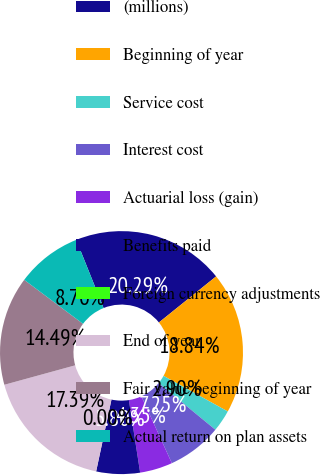Convert chart to OTSL. <chart><loc_0><loc_0><loc_500><loc_500><pie_chart><fcel>(millions)<fcel>Beginning of year<fcel>Service cost<fcel>Interest cost<fcel>Actuarial loss (gain)<fcel>Benefits paid<fcel>Foreign currency adjustments<fcel>End of year<fcel>Fair value beginning of year<fcel>Actual return on plan assets<nl><fcel>20.29%<fcel>18.84%<fcel>2.9%<fcel>7.25%<fcel>4.35%<fcel>5.8%<fcel>0.0%<fcel>17.39%<fcel>14.49%<fcel>8.7%<nl></chart> 